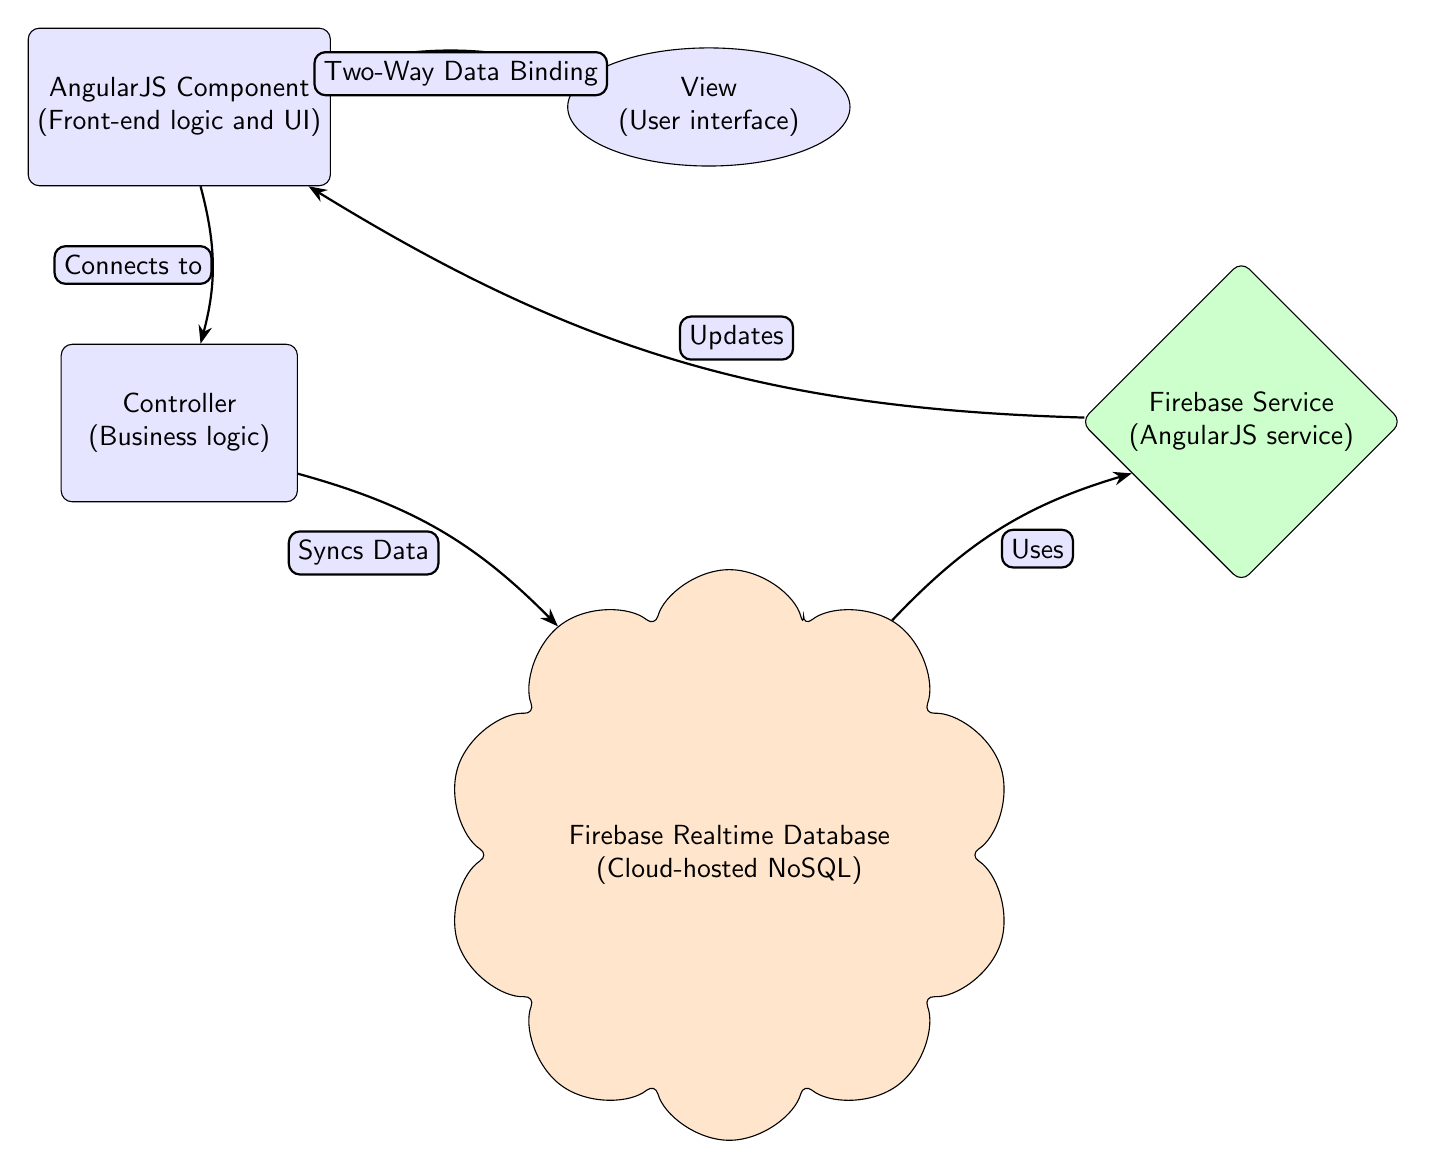What are the components included in the diagram? The diagram includes five components: AngularJS Component, View, Controller, Firebase Realtime Database, and Firebase Service.
Answer: AngularJS Component, View, Controller, Firebase Realtime Database, Firebase Service How many edges are there in the diagram? The diagram features four edges connecting the nodes.
Answer: 4 Which node is connected to the Controller? The component connects to the Controller as indicated by the labeled edge "Connects to."
Answer: Component What type of data binding is illustrated between the AngularJS Component and the View? The edge between the AngularJS Component and the View is labeled "Two-Way Data Binding," indicating the type of data binding.
Answer: Two-Way Data Binding What does the Firebase Service do in relation to the component? The edge indicates that the Firebase Service "Updates" the component, showing its role in the data flow.
Answer: Updates Which nodes communicate through the "Syncs Data" relationship? The Controller and Firebase Realtime Database are linked by the "Syncs Data" relationship, demonstrating the flow of data.
Answer: Controller and Firebase Realtime Database What is the shape of the Firebase Realtime Database node? The Firebase Realtime Database node is shaped like a cloud, indicated by its visual representation in the diagram.
Answer: Cloud How does the Firebase Realtime Database connect to the Firebase Service? The edge labeled "Uses" represents the relationship between the Firebase Realtime Database and the Firebase Service, indicating dependency.
Answer: Uses Which component is responsible for business logic according to the diagram? The Controller is identified as the component responsible for business logic, located below the AngularJS Component.
Answer: Controller 